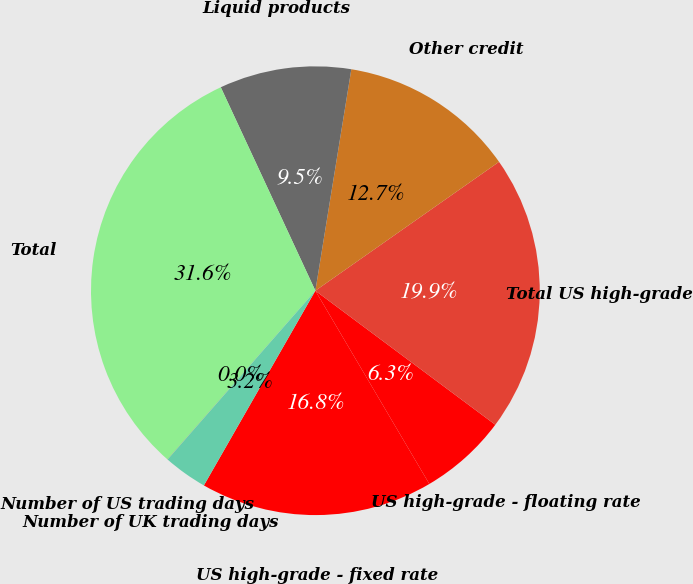Convert chart to OTSL. <chart><loc_0><loc_0><loc_500><loc_500><pie_chart><fcel>US high-grade - fixed rate<fcel>US high-grade - floating rate<fcel>Total US high-grade<fcel>Other credit<fcel>Liquid products<fcel>Total<fcel>Number of US trading days<fcel>Number of UK trading days<nl><fcel>16.76%<fcel>6.33%<fcel>19.93%<fcel>12.7%<fcel>9.49%<fcel>31.62%<fcel>0.01%<fcel>3.17%<nl></chart> 